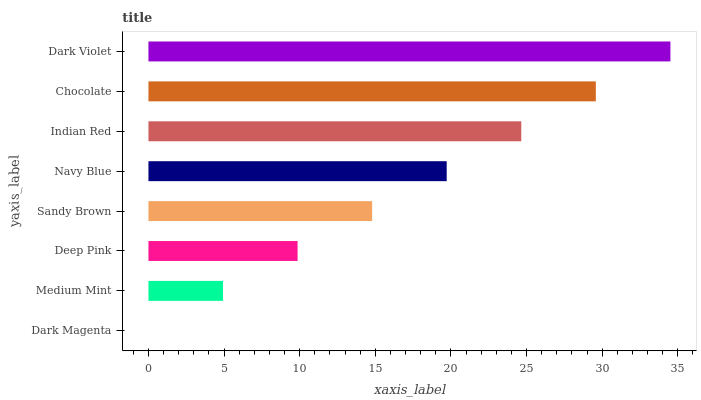Is Dark Magenta the minimum?
Answer yes or no. Yes. Is Dark Violet the maximum?
Answer yes or no. Yes. Is Medium Mint the minimum?
Answer yes or no. No. Is Medium Mint the maximum?
Answer yes or no. No. Is Medium Mint greater than Dark Magenta?
Answer yes or no. Yes. Is Dark Magenta less than Medium Mint?
Answer yes or no. Yes. Is Dark Magenta greater than Medium Mint?
Answer yes or no. No. Is Medium Mint less than Dark Magenta?
Answer yes or no. No. Is Navy Blue the high median?
Answer yes or no. Yes. Is Sandy Brown the low median?
Answer yes or no. Yes. Is Chocolate the high median?
Answer yes or no. No. Is Dark Violet the low median?
Answer yes or no. No. 